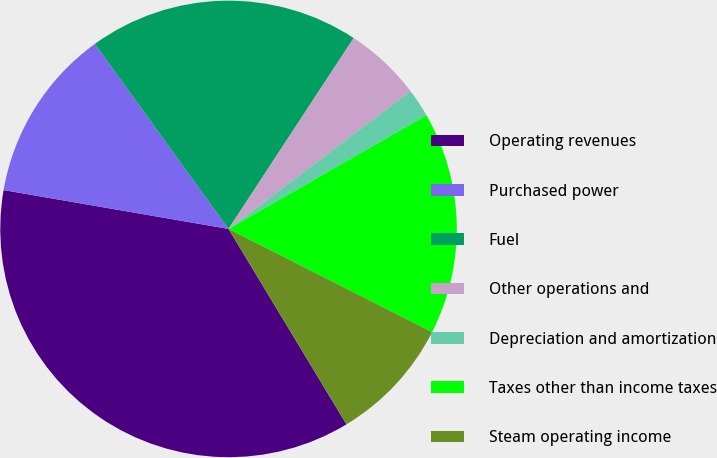Convert chart. <chart><loc_0><loc_0><loc_500><loc_500><pie_chart><fcel>Operating revenues<fcel>Purchased power<fcel>Fuel<fcel>Other operations and<fcel>Depreciation and amortization<fcel>Taxes other than income taxes<fcel>Steam operating income<nl><fcel>36.36%<fcel>12.32%<fcel>19.19%<fcel>5.45%<fcel>2.02%<fcel>15.76%<fcel>8.89%<nl></chart> 